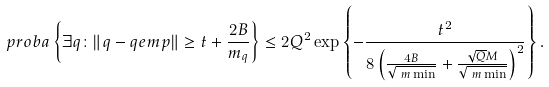<formula> <loc_0><loc_0><loc_500><loc_500>\ p r o b a & \left \{ \exists q \colon \| \L q - \L q e m p \| \geq t + \frac { 2 B } { m _ { q } } \right \} \leq 2 Q ^ { 2 } \exp \left \{ - \frac { t ^ { 2 } } { 8 \left ( \frac { 4 B } { \sqrt { \ m \min } } + \frac { \sqrt { Q } M } { \sqrt { \ m \min } } \right ) ^ { 2 } } \right \} .</formula> 